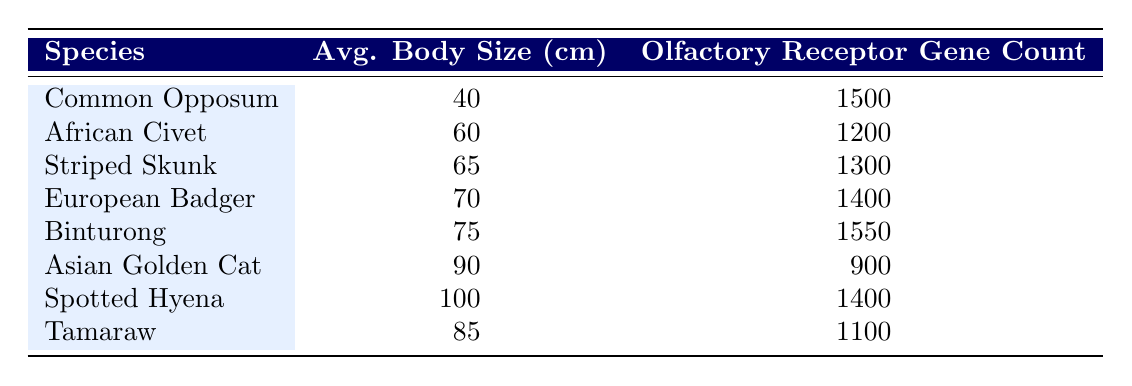What is the olfactory receptor gene count for the Binturong? The table directly lists the Binturong's olfactory receptor gene count as 1550.
Answer: 1550 What is the average body size of the Common Opposum? According to the table, the average body size of the Common Opposum is listed as 40 cm.
Answer: 40 cm Which species has the highest olfactory receptor gene count? By examining the olfactory receptor gene counts in the table, the Binturong has the highest count at 1550, more than any other species listed.
Answer: Binturong What is the average body size (cm) of species with more than 1400 olfactory receptor genes? The species with more than 1400 olfactory receptor genes are Binturong (75 cm), Spotted Hyena (100 cm), and European Badger (70 cm). Their average can be calculated as (75 + 100 + 70) / 3 = 245 / 3 = 81.67 cm.
Answer: 81.67 cm Is the olfactory receptor gene count of the Asian Golden Cat less than the average for the listed species? The Asian Golden Cat has an olfactory receptor gene count of 900. First, we find the average of all species: (1500 + 1200 + 1300 + 1400 + 1550 + 900 + 1400 + 1100) / 8 = 1312.5. Since 900 is less than 1312.5, the answer is yes.
Answer: Yes What is the difference in average body size between the Spotted Hyena and the Common Opposum? The average body size of the Spotted Hyena is 100 cm, and for the Common Opposum, it is 40 cm. To find the difference, we subtract 40 cm from 100 cm: 100 - 40 = 60 cm.
Answer: 60 cm Are there any species with an olfactory receptor gene count above 1500? The only species with an olfactory receptor gene count above 1500 is the Binturong (1550). Therefore, the answer is yes.
Answer: Yes What is the combined olfactory receptor gene count of the African Civet and the Tamaraw? The olfactory receptor gene count for the African Civet is 1200, and for the Tamaraw, it is 1100. Adding these together: 1200 + 1100 = 2300.
Answer: 2300 